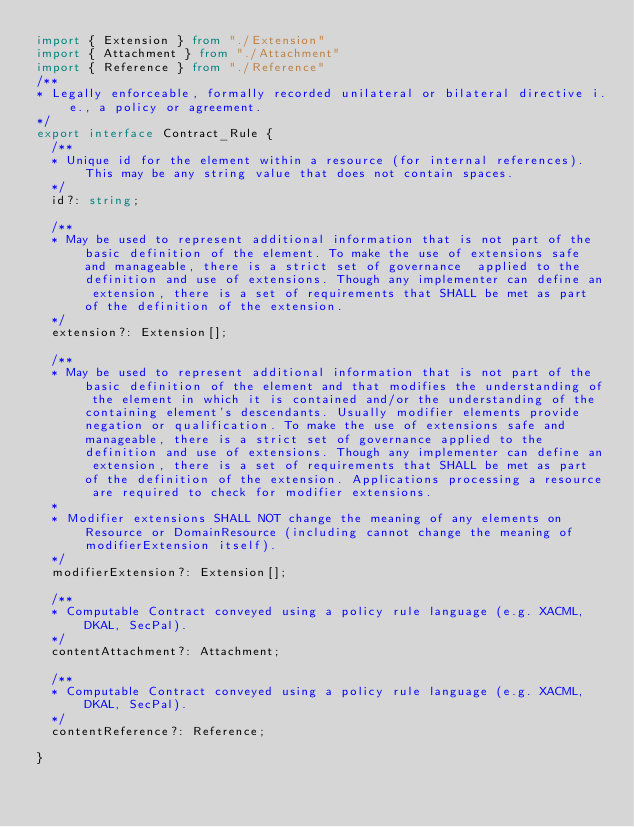Convert code to text. <code><loc_0><loc_0><loc_500><loc_500><_TypeScript_>import { Extension } from "./Extension"
import { Attachment } from "./Attachment"
import { Reference } from "./Reference"
/**
* Legally enforceable, formally recorded unilateral or bilateral directive i.e., a policy or agreement.
*/
export interface Contract_Rule {
  /**
  * Unique id for the element within a resource (for internal references). This may be any string value that does not contain spaces.
  */
  id?: string;

  /**
  * May be used to represent additional information that is not part of the basic definition of the element. To make the use of extensions safe and manageable, there is a strict set of governance  applied to the definition and use of extensions. Though any implementer can define an extension, there is a set of requirements that SHALL be met as part of the definition of the extension.
  */
  extension?: Extension[];

  /**
  * May be used to represent additional information that is not part of the basic definition of the element and that modifies the understanding of the element in which it is contained and/or the understanding of the containing element's descendants. Usually modifier elements provide negation or qualification. To make the use of extensions safe and manageable, there is a strict set of governance applied to the definition and use of extensions. Though any implementer can define an extension, there is a set of requirements that SHALL be met as part of the definition of the extension. Applications processing a resource are required to check for modifier extensions.
  * 
  * Modifier extensions SHALL NOT change the meaning of any elements on Resource or DomainResource (including cannot change the meaning of modifierExtension itself).
  */
  modifierExtension?: Extension[];

  /**
  * Computable Contract conveyed using a policy rule language (e.g. XACML, DKAL, SecPal).
  */
  contentAttachment?: Attachment;

  /**
  * Computable Contract conveyed using a policy rule language (e.g. XACML, DKAL, SecPal).
  */
  contentReference?: Reference;

}
</code> 